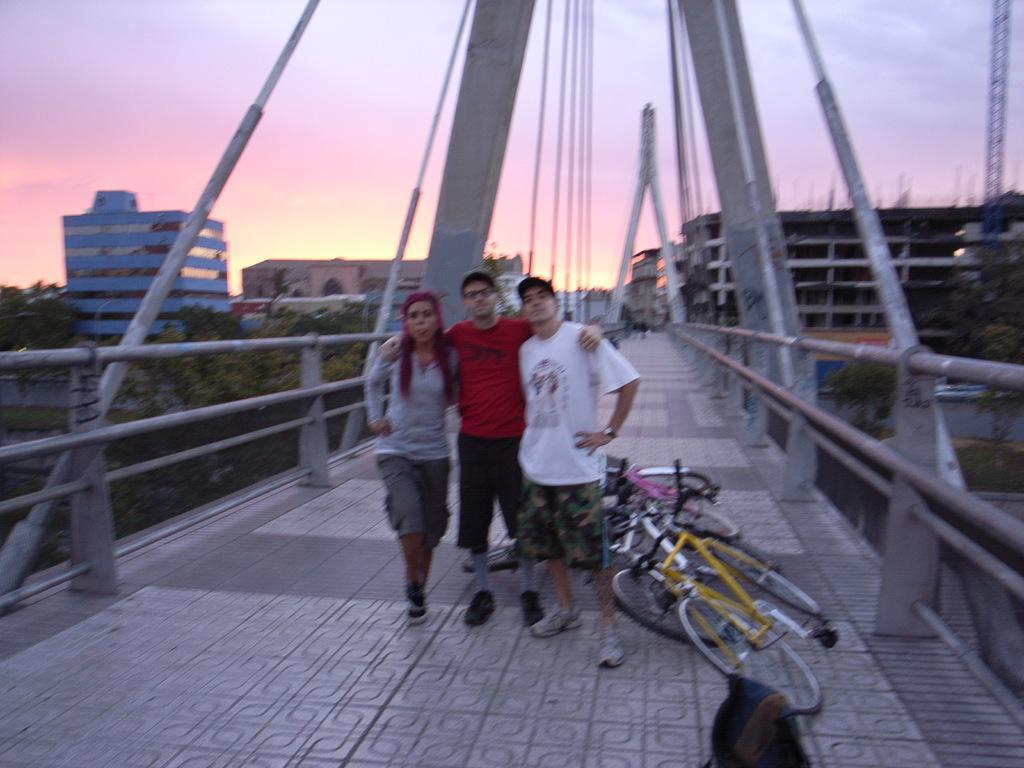Can you describe this image briefly? In this picture I can see few people are standing on the bridge, side there are few bicycles placed, behind there are some buildings and trees. 